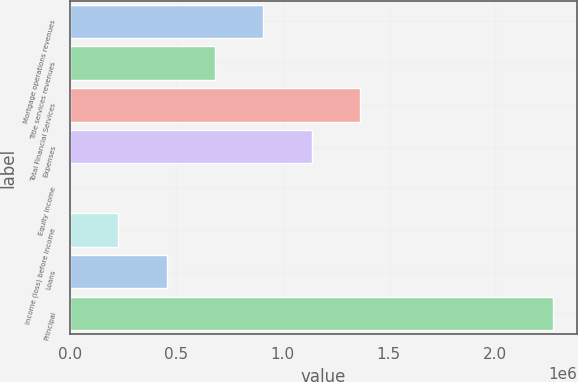Convert chart to OTSL. <chart><loc_0><loc_0><loc_500><loc_500><bar_chart><fcel>Mortgage operations revenues<fcel>Title services revenues<fcel>Total Financial Services<fcel>Expenses<fcel>Equity income<fcel>Income (loss) before income<fcel>Loans<fcel>Principal<nl><fcel>909241<fcel>681948<fcel>1.36383e+06<fcel>1.13653e+06<fcel>68<fcel>227361<fcel>454654<fcel>2.273e+06<nl></chart> 